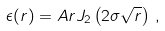<formula> <loc_0><loc_0><loc_500><loc_500>\epsilon ( r ) = A r J _ { 2 } \left ( 2 \sigma \sqrt { r } \right ) \, ,</formula> 